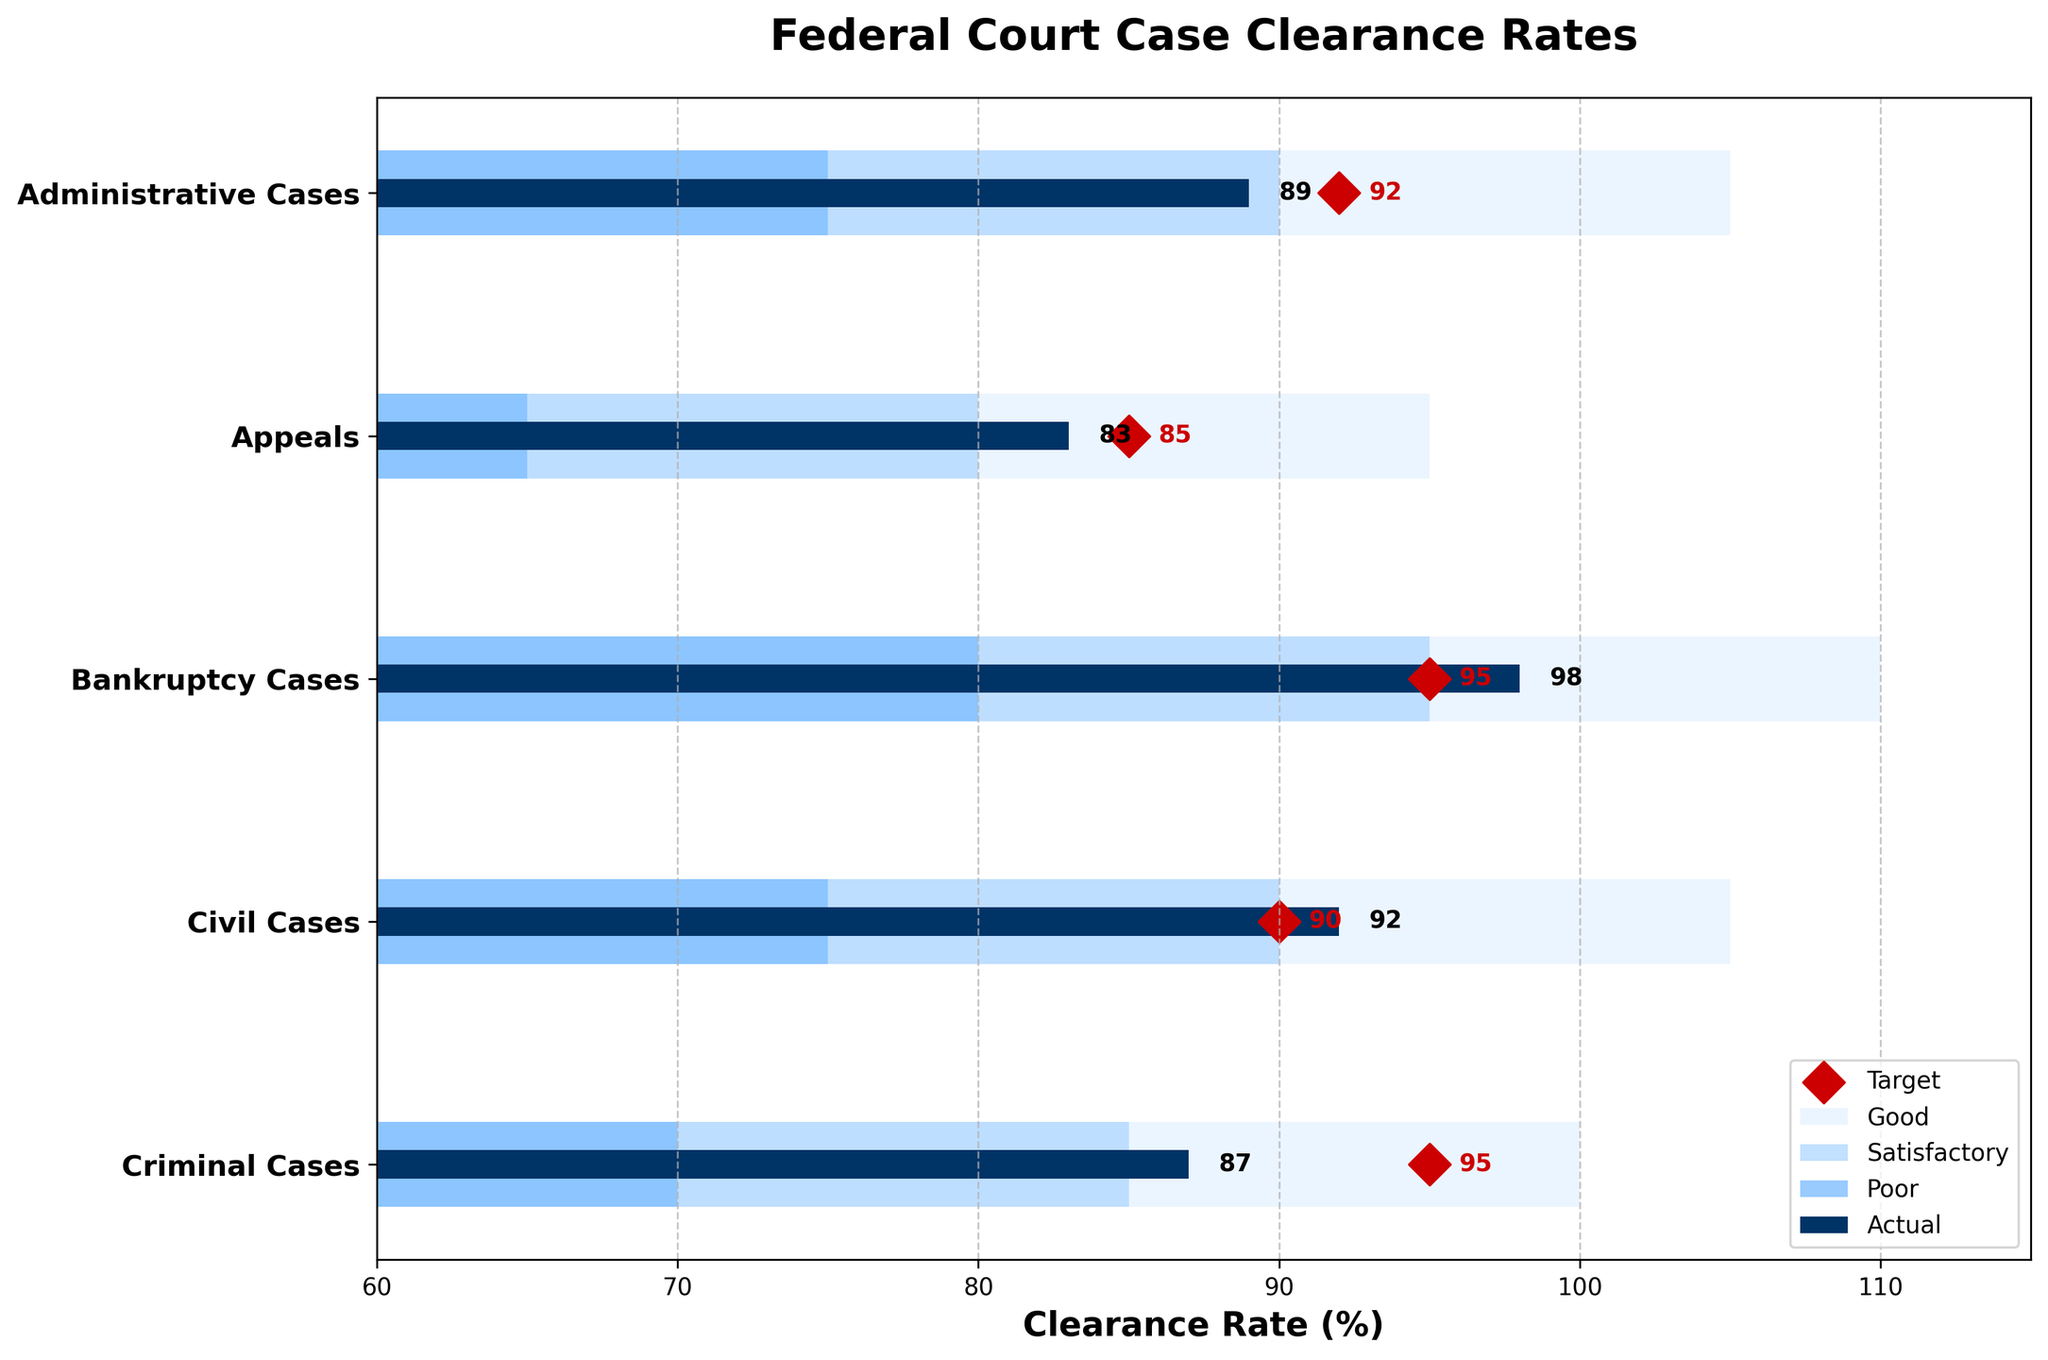What is the title of the figure? The title of the figure can be found at the top of the chart. It is typically highlighted and uses a larger font size. From the data provided, the title is: "Federal Court Case Clearance Rates".
Answer: Federal Court Case Clearance Rates What category has the highest actual clearance rate? To find the category with the highest actual clearance rate, refer to the highest bar labeled as "Actual" which can be identified by its unique color (dark blue). By looking at the bars, "Bankruptcy Cases" has the highest actual rate of 98.
Answer: Bankruptcy Cases What is the actual clearance rate for Appeals? Look for the bar labeled "Actual" in the "Appeals" category. The numerical value can also be found close to the end of the bar.
Answer: 83 Which categories did not meet their target clearance rate? Compare the actual clearance rate for each category with its corresponding target marker (red diamond). Categories where the actual bar does not reach the target diamond did not meet their target. These categories are "Criminal Cases," "Bankruptcy Cases," and "Appeals."
Answer: Criminal Cases, Bankruptcy Cases, Appeals How many categories exceeded their target clearance rate? Check how many actual bars surpass their corresponding target diamond markers. For those categories, the actual clearance rate is greater than the target. The categories that exceed their targets are "Civil Cases" and "Administrative Cases".
Answer: 2 What is the difference between the actual and target clearance rates for Administrative Cases? Subtract the actual clearance rate value for "Administrative Cases" from its target clearance rate. Actual is 89, and Target is 92. So, 92 - 89 = 3.
Answer: 3 Which category has the smallest difference between the actual and target clearance rates? Calculate the difference between the actual and target clearance rates for each category, then identify the smallest difference. Differences are: Criminal Cases: 8, Civil Cases: 2, Bankruptcy Cases: 3, Appeals: 2, Administrative Cases: 3. The smallest difference is 2 for "Civil Cases" and "Appeals."
Answer: Civil Cases, Appeals What color indicates the "Good" range in the chart? Identify the portion of the background bar that represents the "Good" range by its unique color (light blue).
Answer: Light blue Which category is closest to its "Satisfactory" level but below "Good"? Check the position of the "Actual" rates relative to their corresponding "Satisfactory" and "Good" ranges. "Criminal Cases" is at 87, which is just above 85 (Satisfactory) but below 100 (Good).
Answer: Criminal Cases 